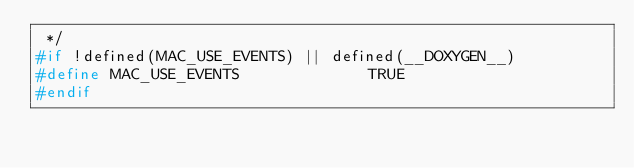Convert code to text. <code><loc_0><loc_0><loc_500><loc_500><_C_> */
#if !defined(MAC_USE_EVENTS) || defined(__DOXYGEN__)
#define MAC_USE_EVENTS              TRUE
#endif
</code> 